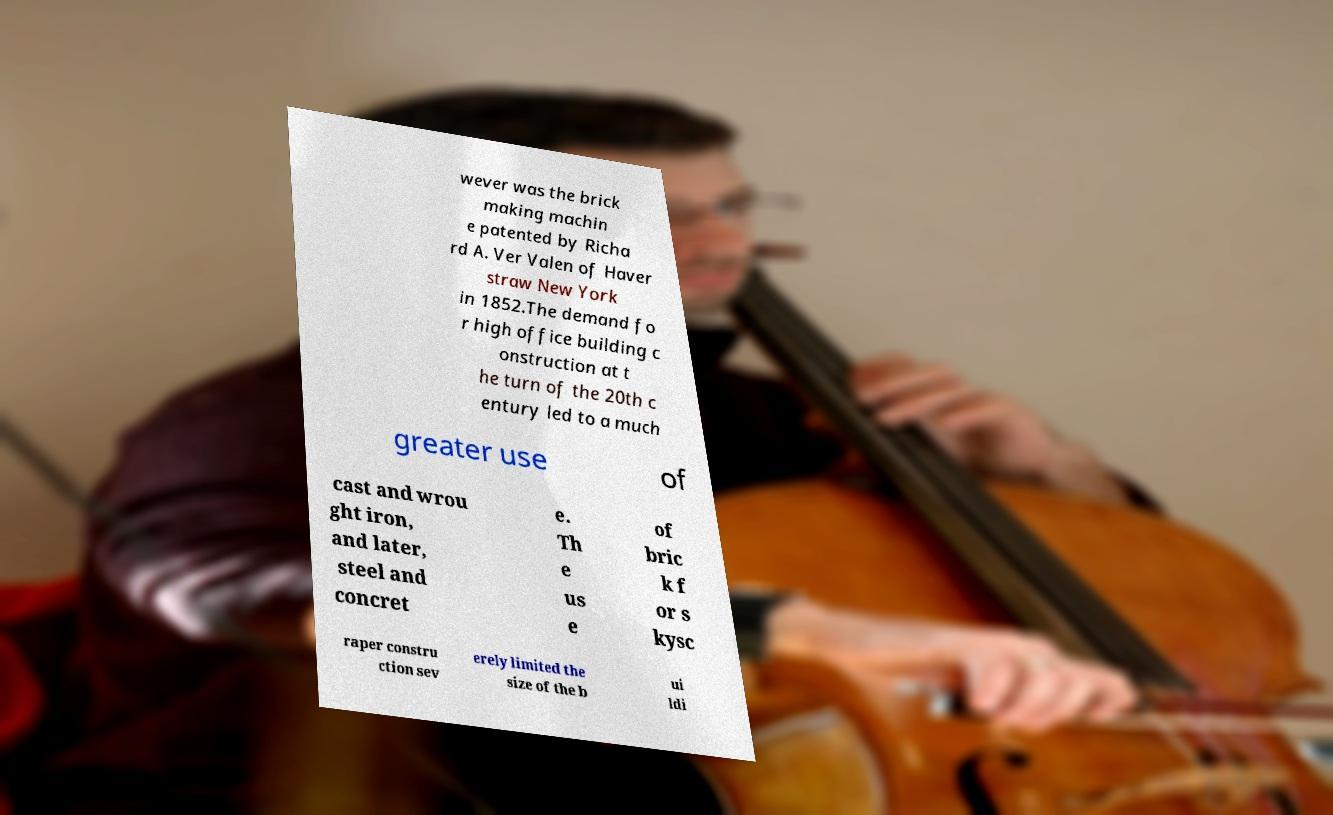Can you accurately transcribe the text from the provided image for me? wever was the brick making machin e patented by Richa rd A. Ver Valen of Haver straw New York in 1852.The demand fo r high office building c onstruction at t he turn of the 20th c entury led to a much greater use of cast and wrou ght iron, and later, steel and concret e. Th e us e of bric k f or s kysc raper constru ction sev erely limited the size of the b ui ldi 